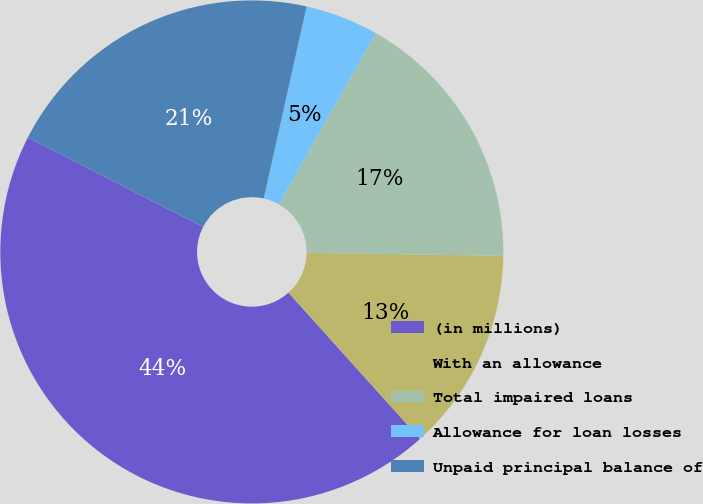Convert chart. <chart><loc_0><loc_0><loc_500><loc_500><pie_chart><fcel>(in millions)<fcel>With an allowance<fcel>Total impaired loans<fcel>Allowance for loan losses<fcel>Unpaid principal balance of<nl><fcel>44.19%<fcel>13.09%<fcel>17.04%<fcel>4.71%<fcel>20.98%<nl></chart> 